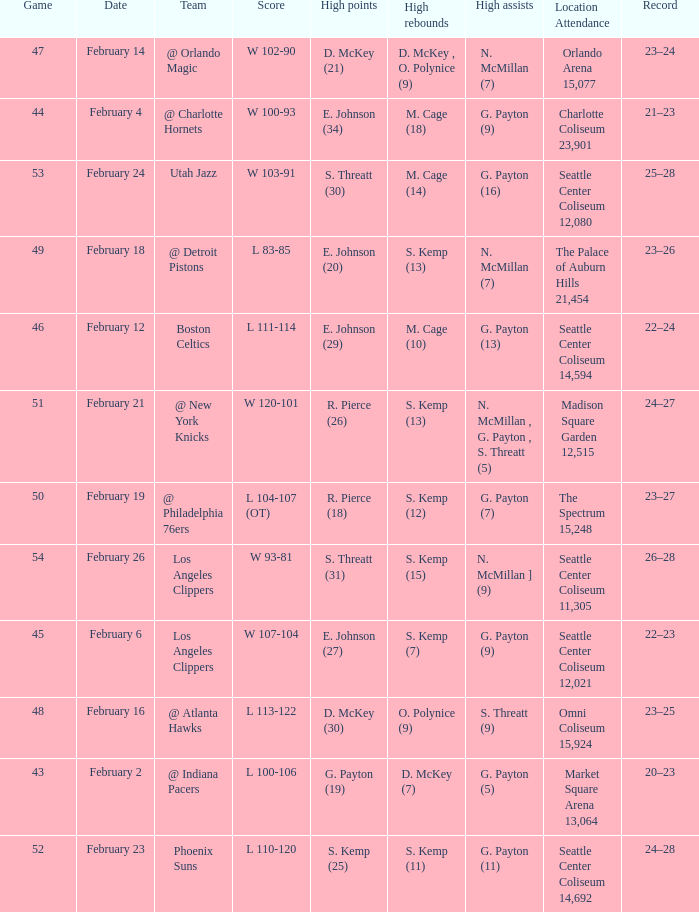What is the record for the Utah Jazz? 25–28. 